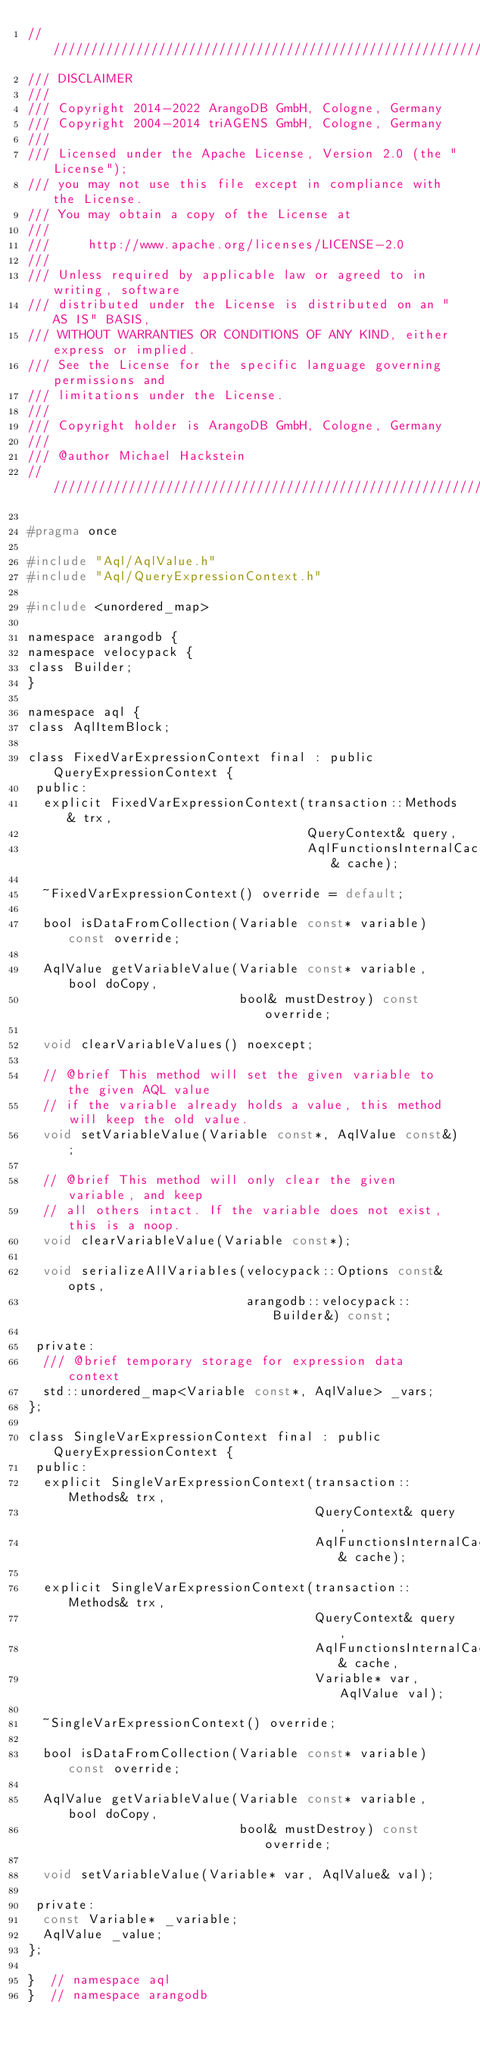<code> <loc_0><loc_0><loc_500><loc_500><_C_>////////////////////////////////////////////////////////////////////////////////
/// DISCLAIMER
///
/// Copyright 2014-2022 ArangoDB GmbH, Cologne, Germany
/// Copyright 2004-2014 triAGENS GmbH, Cologne, Germany
///
/// Licensed under the Apache License, Version 2.0 (the "License");
/// you may not use this file except in compliance with the License.
/// You may obtain a copy of the License at
///
///     http://www.apache.org/licenses/LICENSE-2.0
///
/// Unless required by applicable law or agreed to in writing, software
/// distributed under the License is distributed on an "AS IS" BASIS,
/// WITHOUT WARRANTIES OR CONDITIONS OF ANY KIND, either express or implied.
/// See the License for the specific language governing permissions and
/// limitations under the License.
///
/// Copyright holder is ArangoDB GmbH, Cologne, Germany
///
/// @author Michael Hackstein
////////////////////////////////////////////////////////////////////////////////

#pragma once

#include "Aql/AqlValue.h"
#include "Aql/QueryExpressionContext.h"

#include <unordered_map>

namespace arangodb {
namespace velocypack {
class Builder;
}

namespace aql {
class AqlItemBlock;

class FixedVarExpressionContext final : public QueryExpressionContext {
 public:
  explicit FixedVarExpressionContext(transaction::Methods& trx,
                                     QueryContext& query,
                                     AqlFunctionsInternalCache& cache);

  ~FixedVarExpressionContext() override = default;

  bool isDataFromCollection(Variable const* variable) const override;

  AqlValue getVariableValue(Variable const* variable, bool doCopy,
                            bool& mustDestroy) const override;

  void clearVariableValues() noexcept;

  // @brief This method will set the given variable to the given AQL value
  // if the variable already holds a value, this method will keep the old value.
  void setVariableValue(Variable const*, AqlValue const&);

  // @brief This method will only clear the given variable, and keep
  // all others intact. If the variable does not exist, this is a noop.
  void clearVariableValue(Variable const*);

  void serializeAllVariables(velocypack::Options const& opts,
                             arangodb::velocypack::Builder&) const;

 private:
  /// @brief temporary storage for expression data context
  std::unordered_map<Variable const*, AqlValue> _vars;
};

class SingleVarExpressionContext final : public QueryExpressionContext {
 public:
  explicit SingleVarExpressionContext(transaction::Methods& trx,
                                      QueryContext& query,
                                      AqlFunctionsInternalCache& cache);

  explicit SingleVarExpressionContext(transaction::Methods& trx,
                                      QueryContext& query,
                                      AqlFunctionsInternalCache& cache,
                                      Variable* var, AqlValue val);

  ~SingleVarExpressionContext() override;

  bool isDataFromCollection(Variable const* variable) const override;

  AqlValue getVariableValue(Variable const* variable, bool doCopy,
                            bool& mustDestroy) const override;

  void setVariableValue(Variable* var, AqlValue& val);

 private:
  const Variable* _variable;
  AqlValue _value;
};

}  // namespace aql
}  // namespace arangodb
</code> 